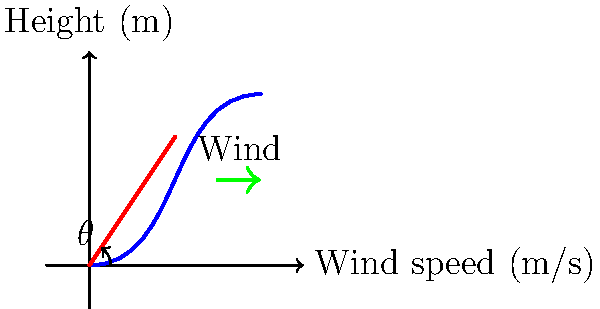As a fishing trip organizer, you need to advise your clients on the optimal casting technique. Given the wind profile shown in the diagram, where wind speed increases with height, what is the optimal angle $\theta$ (in degrees, rounded to the nearest whole number) for casting a fishing line to maximize distance while considering wind resistance? To determine the optimal casting angle, we need to consider the following factors:

1. In still air, the optimal angle for maximum distance would be 45°.
2. With wind resistance, the optimal angle is typically less than 45°.
3. The wind speed increases with height, which means higher trajectories will face more resistance.

Given these considerations:

1. We want to keep the line's trajectory relatively low to minimize wind resistance.
2. However, we still need some height to achieve distance.
3. A good compromise is to aim for an angle between 30° and 40°.

Looking at the diagram:

1. The red line represents the fishing rod and line at the moment of cast.
2. The angle $\theta$ is formed between the horizontal and the rod.
3. Using the grid, we can estimate that the rod is at a position of approximately (2,3).

To calculate the angle:

$$\theta = \arctan(\frac{3}{2}) \approx 56.3°$$

This angle is too high given our wind conditions. We should adjust it down to the 30°-40° range.

A good choice would be around 35°, which balances the need for some height while keeping the trajectory relatively low to minimize wind resistance.
Answer: 35° 